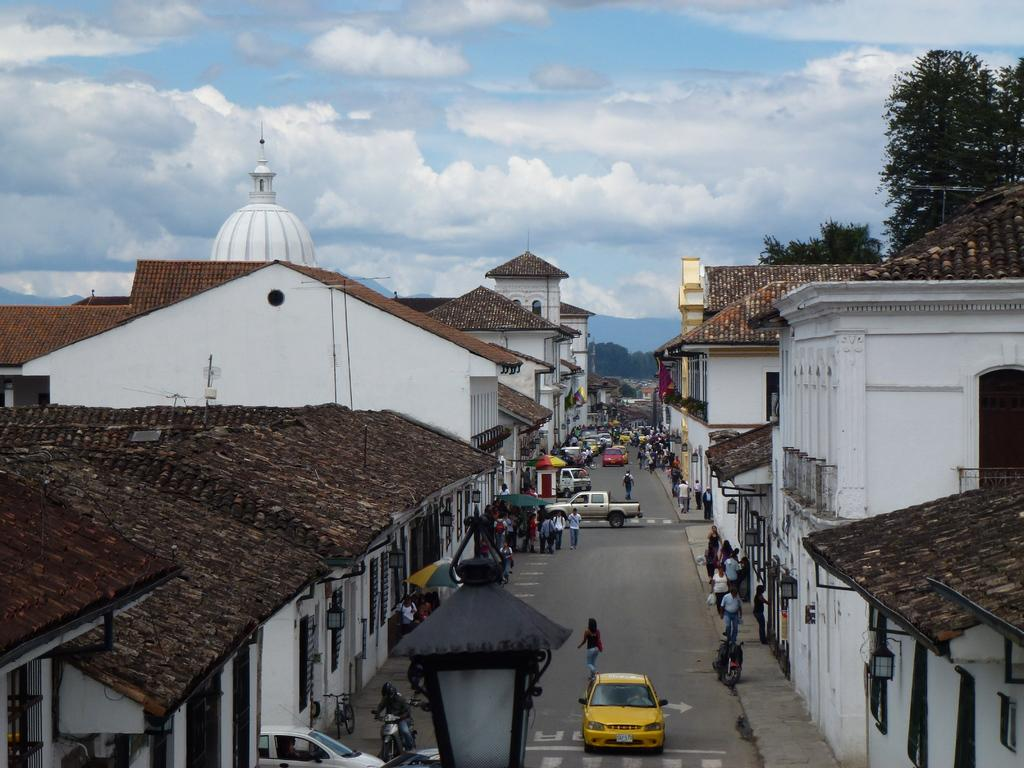Who or what can be seen in the image? There are people in the image. What else is present in the image besides people? There are vehicles on the road, lights, buildings, trees in the background, and the sky with clouds visible in the background. Can you describe the vehicles in the image? The vehicles on the road are not specified, but they are likely cars, buses, or other forms of transportation. What type of environment is depicted in the image? The image shows an urban or city setting, with buildings, roads, and vehicles. What type of pie is being served on the table in the image? There is no table or pie present in the image; it features people, vehicles, lights, buildings, trees, and the sky with clouds. 